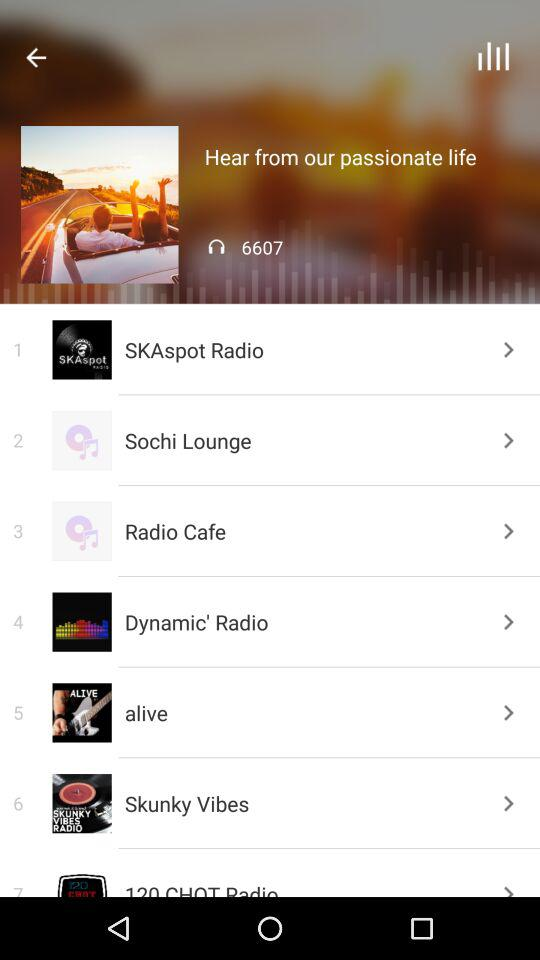How many people are listening to the current song? There are currently 6607 listeners. 